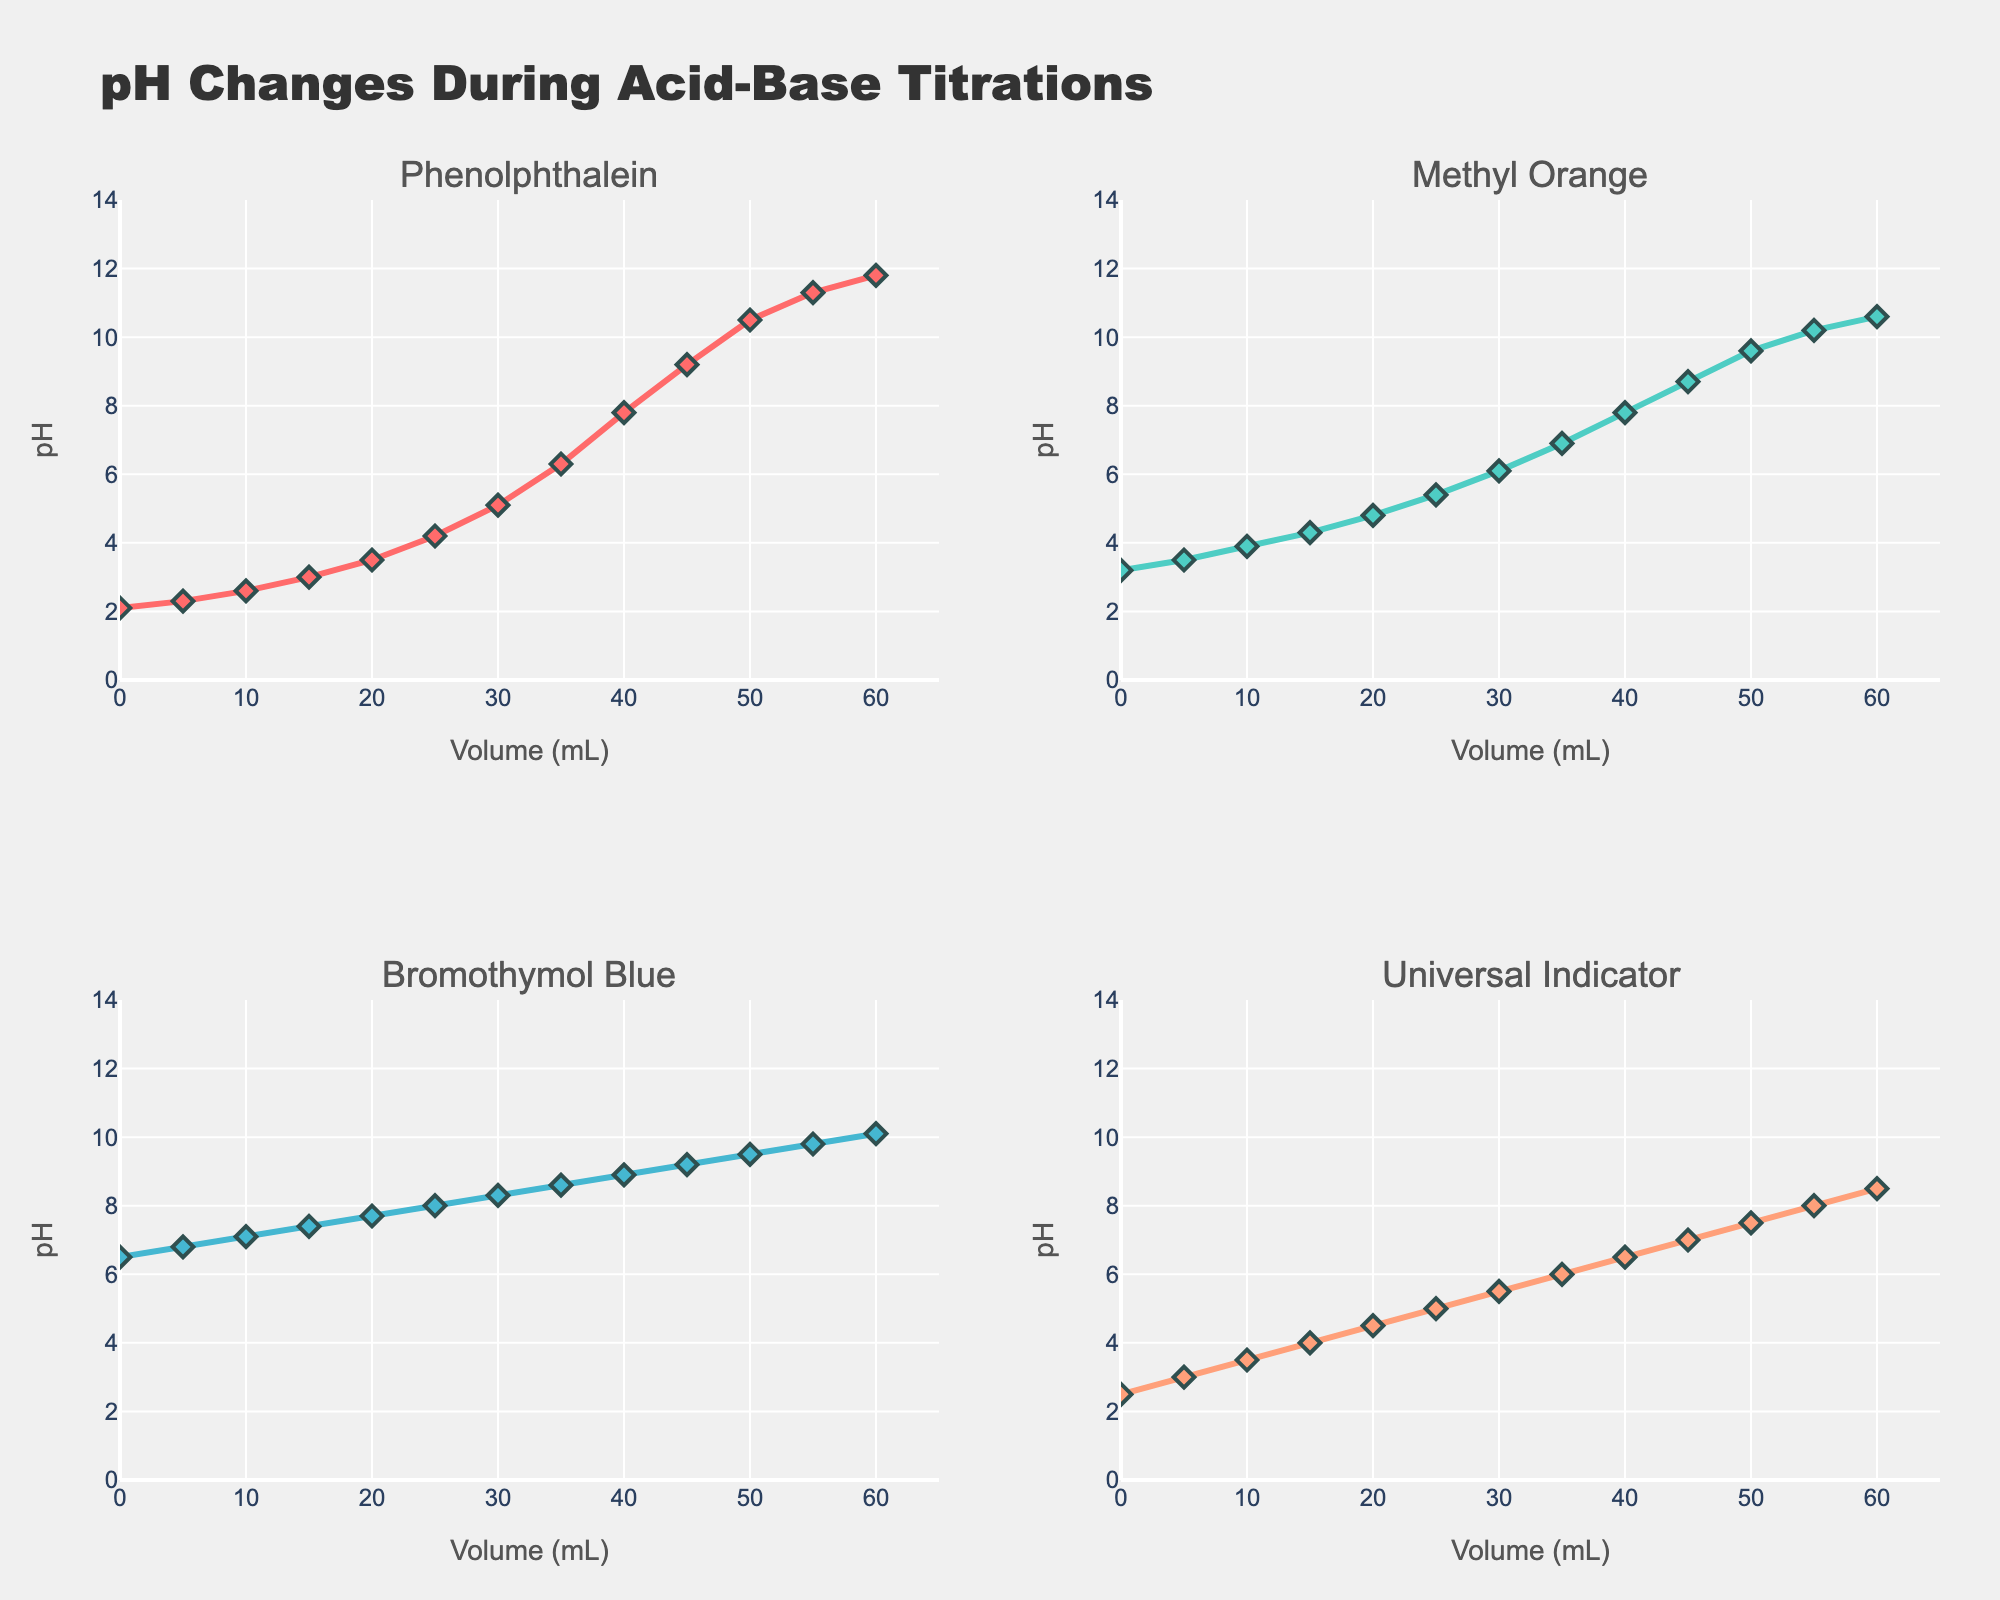Which library has the shortest query time for 10 MB datasets? The figure shows the query times (in milliseconds) for each library at different dataset sizes represented as bubble charts. By looking at the first subplot and locating the 10 MB dataset size on the x-axis, ROM has the smallest bubble size indicating the shortest query time.
Answer: ROM How many libraries have a query time of less than 150 ms for 1000 MB datasets? In the first subplot, focus on the data points for the 1000 MB dataset size. Identify the bubbles corresponding to query times less than 150 ms. ROM, Sequel, and Hanami::Model meet this criterion, totaling to three libraries.
Answer: 3 What's the average throughput for the dataset size of 100 MB across all libraries? In the second subplot, locate the bubbles at the 100 MB dataset size and note their throughput values. The throughput values are 313, 286, 263, 238, and 222. Summing these values yields 1322, and dividing by the 5 libraries gives an average of 264.4 queries/second.
Answer: 264.4 Which library has the highest throughput for a 10 MB dataset? The second subplot shows throughput on the y-axis and dataset sizes on the x-axis. For the 10 MB dataset size, ROM has the largest bubble indicating the highest throughput.
Answer: ROM Does Hanami::Model have a higher throughput than DataMapper for a 100 MB dataset? In the second subplot, locate the bubbles for Hanami::Model and DataMapper at the 100 MB dataset size. Hanami::Model has a throughput of 286 queries/sec while DataMapper has 238 queries/sec, confirming Hanami::Model has a higher throughput.
Answer: Yes Which library's query time increases the most when moving from a 100 MB dataset to a 1000 MB dataset? Look at the first subplot and compare the differences in query time for each library when the dataset size increases from 100 MB to 1000 MB. ActiveRecord increases from 45 ms to 180 ms (135 ms increase), exhibiting the largest change.
Answer: ActiveRecord How does the ranking of throughput for 1000 MB datasets compare to that for 10 MB datasets among the libraries? For the 1000 MB dataset size in the second subplot, ROM has the highest throughput followed by Sequel, Hanami::Model, DataMapper, and ActiveRecord. For 10 MB, ROM again has the highest throughput, followed by Hanami::Model, Sequel, DataMapper, and ActiveRecord. The relative ranking maintains ROM at the top and ActiveRecord at the bottom, but the middle rankings shift.
Answer: Similar with variations in the middle rankings Which library, if any, shows consistent improvement in throughput as the dataset size increases? In the second subplot, analyze the trend of each library's data points. None of the libraries show consistent improvement; throughput generally decreases as dataset size increases.
Answer: None Which library has the largest bubble size for query time in the 100 MB dataset? In the first subplot for the 100 MB dataset, compare the bubble sizes. ActiveRecord has the largest bubble size indicating the longest query time.
Answer: ActiveRecord 